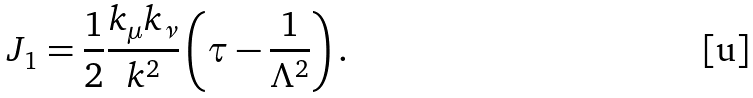<formula> <loc_0><loc_0><loc_500><loc_500>J _ { 1 } = \frac { 1 } { 2 } \frac { k _ { \mu } k _ { \nu } } { k ^ { 2 } } \left ( \tau - \frac { 1 } { \Lambda ^ { 2 } } \right ) .</formula> 